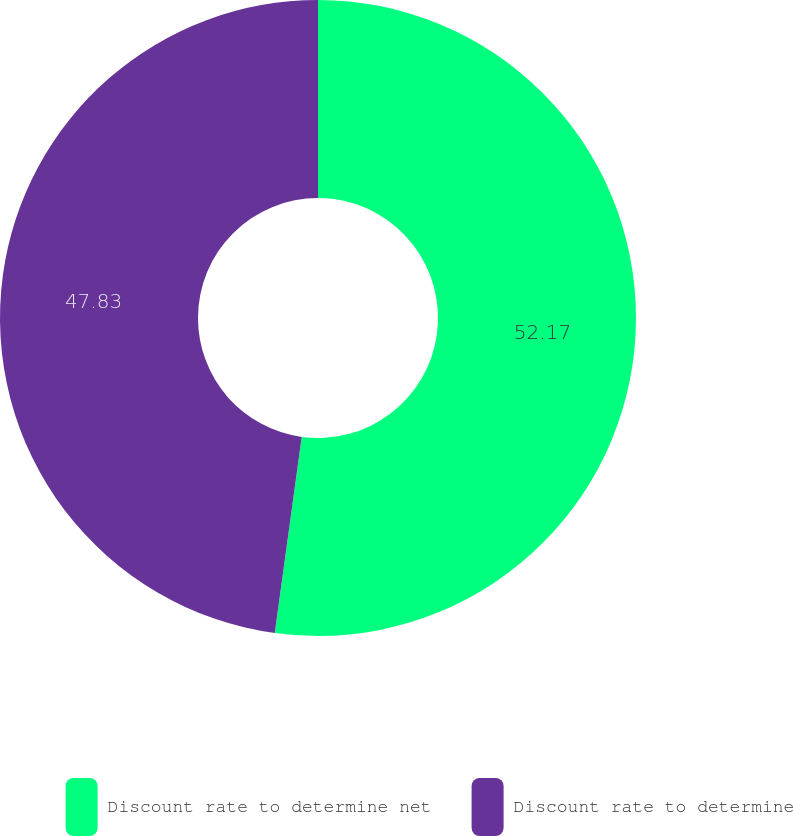Convert chart to OTSL. <chart><loc_0><loc_0><loc_500><loc_500><pie_chart><fcel>Discount rate to determine net<fcel>Discount rate to determine<nl><fcel>52.17%<fcel>47.83%<nl></chart> 